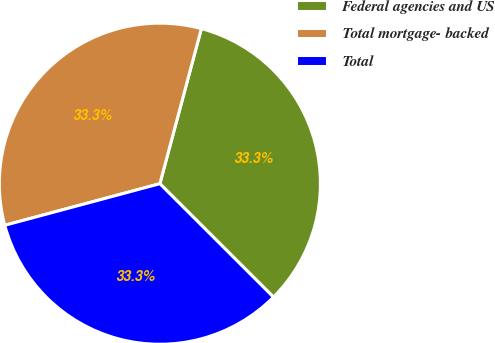Convert chart. <chart><loc_0><loc_0><loc_500><loc_500><pie_chart><fcel>Federal agencies and US<fcel>Total mortgage- backed<fcel>Total<nl><fcel>33.32%<fcel>33.33%<fcel>33.34%<nl></chart> 